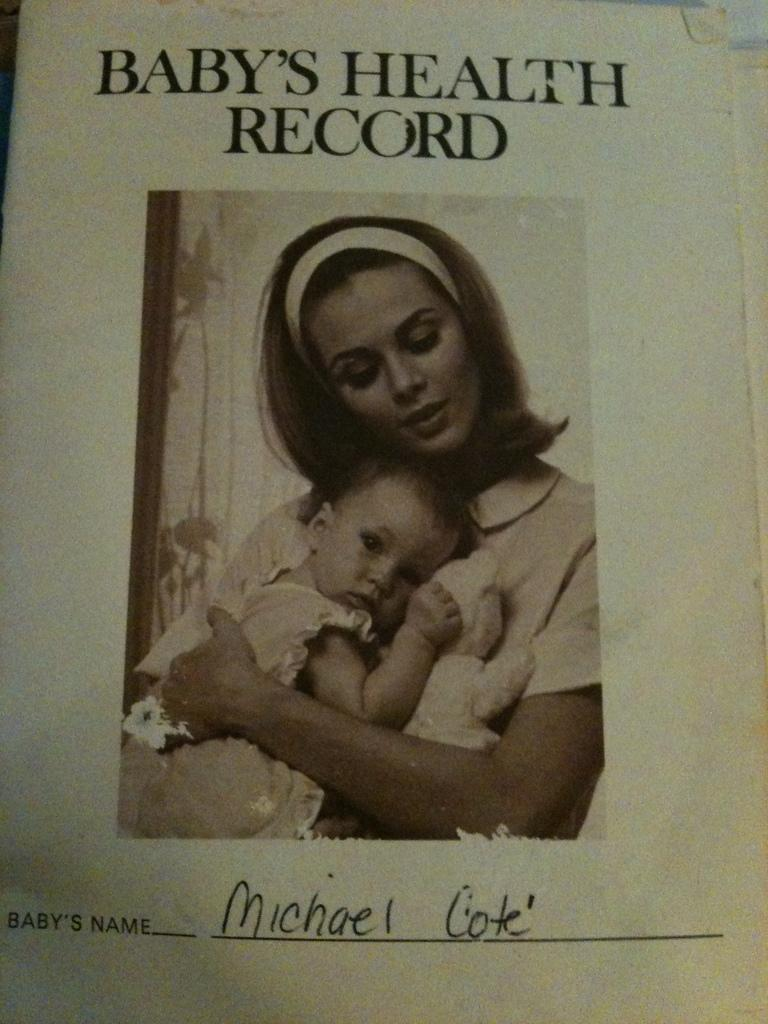What is the person in the image doing with their hands? The person is holding a baby in the image. What else can be seen in the image besides the person and the baby? There is a paper with writing on it in the image. Reasoning: Let' Let's think step by step in order to produce the conversation. We start by identifying the main subjects in the image, which are the person and the baby. Then, we expand the conversation to include the paper with writing on it, which is another object visible in the image. Each question is designed to elicit a specific detail about the image that is known from the provided facts. Absurd Question/Answer: What type of fruit is being discussed in the image? There is no fruit or discussion present in the image; it features a person holding a baby and a paper with writing on it. What type of change is being made to the quince in the image? There is no quince or change present in the image; it features a person holding a baby and a paper with writing on it. 